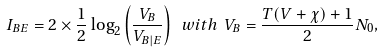Convert formula to latex. <formula><loc_0><loc_0><loc_500><loc_500>I _ { B E } = 2 \times \frac { 1 } { 2 } \log _ { 2 } \left ( \frac { V _ { B } } { V _ { B | E } } \right ) \ w i t h \ V _ { B } = \frac { T ( V + \chi ) + 1 } { 2 } N _ { 0 } ,</formula> 